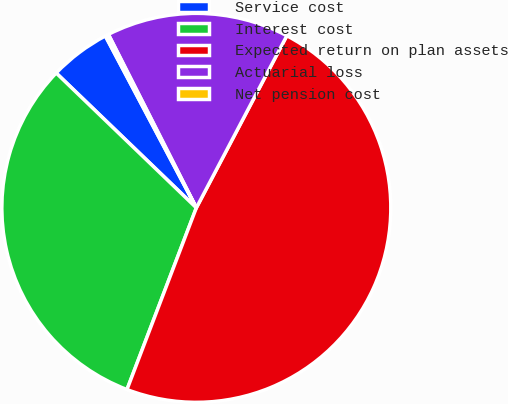Convert chart to OTSL. <chart><loc_0><loc_0><loc_500><loc_500><pie_chart><fcel>Service cost<fcel>Interest cost<fcel>Expected return on plan assets<fcel>Actuarial loss<fcel>Net pension cost<nl><fcel>5.06%<fcel>31.39%<fcel>48.1%<fcel>15.17%<fcel>0.28%<nl></chart> 